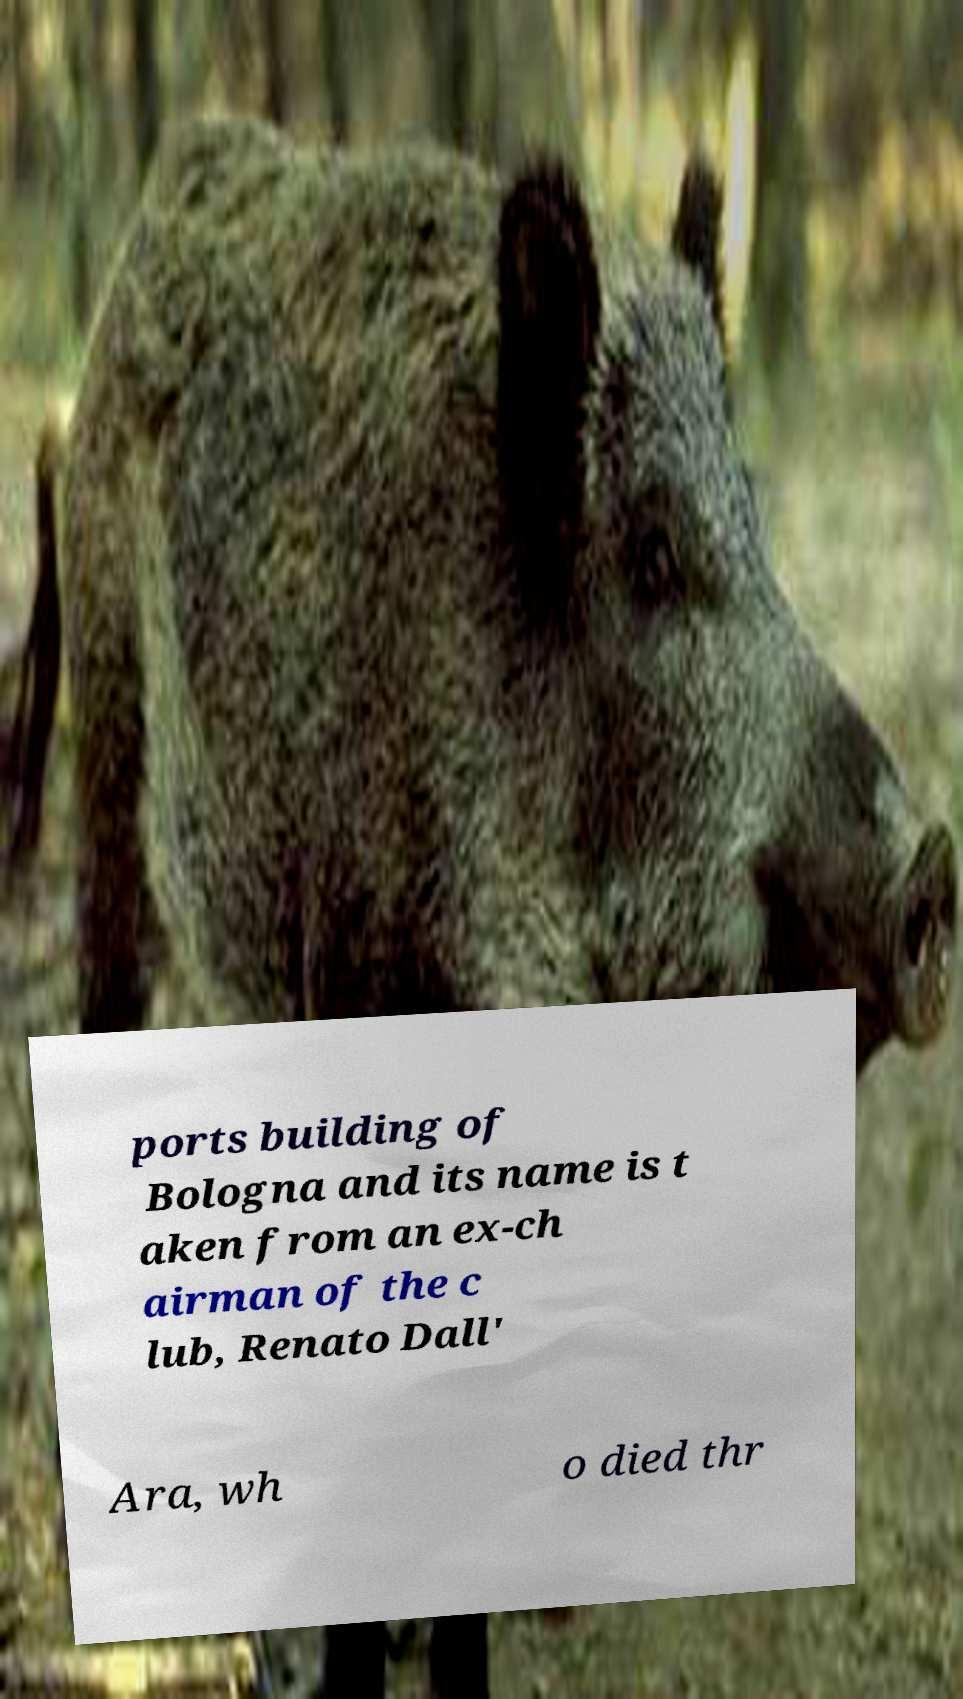There's text embedded in this image that I need extracted. Can you transcribe it verbatim? ports building of Bologna and its name is t aken from an ex-ch airman of the c lub, Renato Dall' Ara, wh o died thr 